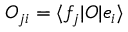Convert formula to latex. <formula><loc_0><loc_0><loc_500><loc_500>O _ { j i } = \langle f _ { j } | O | e _ { i } \rangle</formula> 